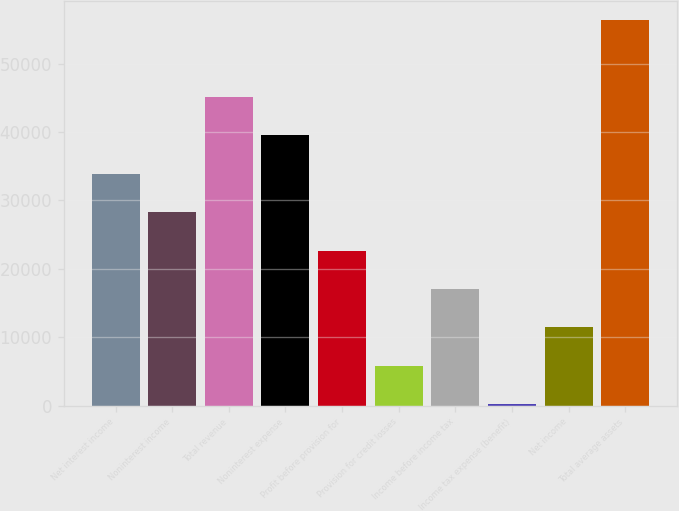Convert chart to OTSL. <chart><loc_0><loc_0><loc_500><loc_500><bar_chart><fcel>Net interest income<fcel>Noninterest income<fcel>Total revenue<fcel>Noninterest expense<fcel>Profit before provision for<fcel>Provision for credit losses<fcel>Income before income tax<fcel>Income tax expense (benefit)<fcel>Net income<fcel>Total average assets<nl><fcel>33909.2<fcel>28289.5<fcel>45148.6<fcel>39528.9<fcel>22669.8<fcel>5810.7<fcel>17050.1<fcel>191<fcel>11430.4<fcel>56388<nl></chart> 